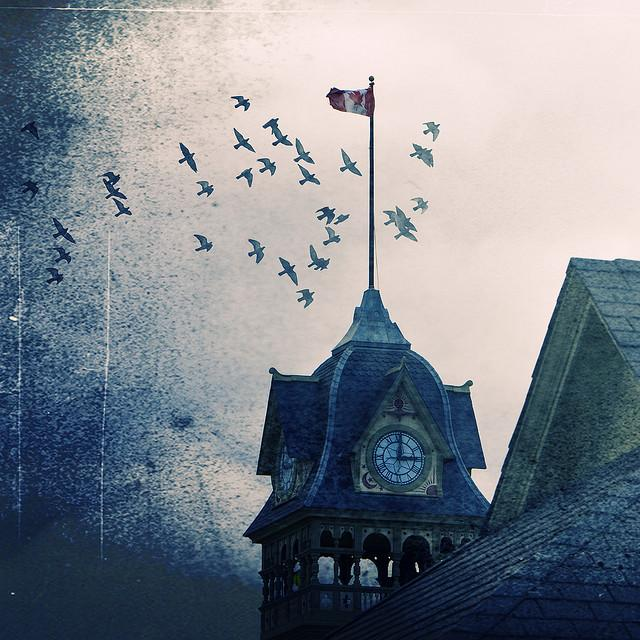What nation's flag are the birds flying towards?

Choices:
A) colombia
B) romania
C) switzerland
D) canada canada 